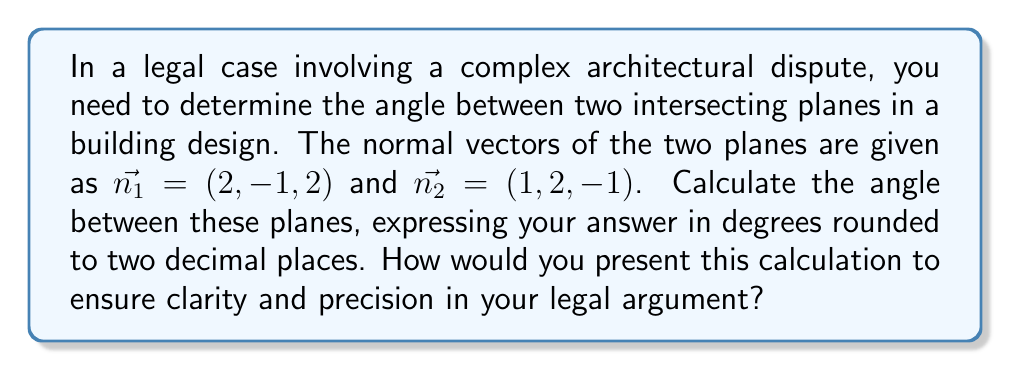Teach me how to tackle this problem. To find the angle between two intersecting planes, we can use the angle between their normal vectors. The process is as follows:

1) The angle $\theta$ between two vectors $\vec{a}$ and $\vec{b}$ is given by the formula:

   $$\cos \theta = \frac{\vec{a} \cdot \vec{b}}{|\vec{a}||\vec{b}|}$$

2) In our case, $\vec{a} = \vec{n_1} = (2, -1, 2)$ and $\vec{b} = \vec{n_2} = (1, 2, -1)$

3) Calculate the dot product $\vec{n_1} \cdot \vec{n_2}$:
   $$(2)(1) + (-1)(2) + (2)(-1) = 2 - 2 - 2 = -2$$

4) Calculate the magnitudes:
   $$|\vec{n_1}| = \sqrt{2^2 + (-1)^2 + 2^2} = \sqrt{9} = 3$$
   $$|\vec{n_2}| = \sqrt{1^2 + 2^2 + (-1)^2} = \sqrt{6}$$

5) Substitute into the formula:
   $$\cos \theta = \frac{-2}{3\sqrt{6}}$$

6) Take the inverse cosine (arccos) of both sides:
   $$\theta = \arccos\left(\frac{-2}{3\sqrt{6}}\right)$$

7) Convert to degrees and round to two decimal places:
   $$\theta \approx 106.60°$$

To present this calculation with clarity and precision in a legal argument, you would:
1) Clearly state the given information and the question at hand.
2) Explain each step of the calculation process.
3) Cite the mathematical principles and formulas used.
4) Show all work, including intermediate calculations.
5) Clearly state the final answer with appropriate units and level of precision.
6) Be prepared to explain the relevance of this calculation to the overall case.
Answer: The angle between the two intersecting planes is approximately 106.60°. 